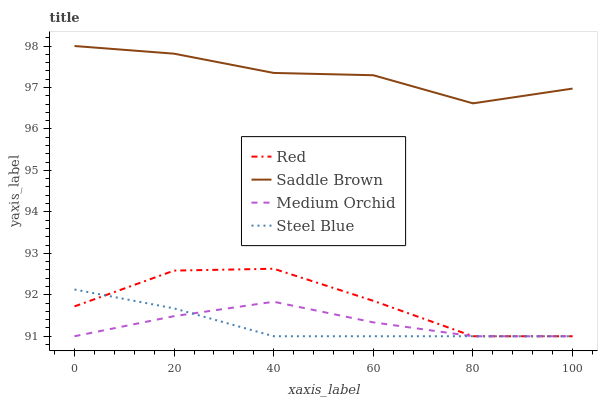Does Steel Blue have the minimum area under the curve?
Answer yes or no. Yes. Does Saddle Brown have the maximum area under the curve?
Answer yes or no. Yes. Does Red have the minimum area under the curve?
Answer yes or no. No. Does Red have the maximum area under the curve?
Answer yes or no. No. Is Steel Blue the smoothest?
Answer yes or no. Yes. Is Red the roughest?
Answer yes or no. Yes. Is Saddle Brown the smoothest?
Answer yes or no. No. Is Saddle Brown the roughest?
Answer yes or no. No. Does Medium Orchid have the lowest value?
Answer yes or no. Yes. Does Saddle Brown have the lowest value?
Answer yes or no. No. Does Saddle Brown have the highest value?
Answer yes or no. Yes. Does Red have the highest value?
Answer yes or no. No. Is Medium Orchid less than Saddle Brown?
Answer yes or no. Yes. Is Saddle Brown greater than Steel Blue?
Answer yes or no. Yes. Does Red intersect Medium Orchid?
Answer yes or no. Yes. Is Red less than Medium Orchid?
Answer yes or no. No. Is Red greater than Medium Orchid?
Answer yes or no. No. Does Medium Orchid intersect Saddle Brown?
Answer yes or no. No. 